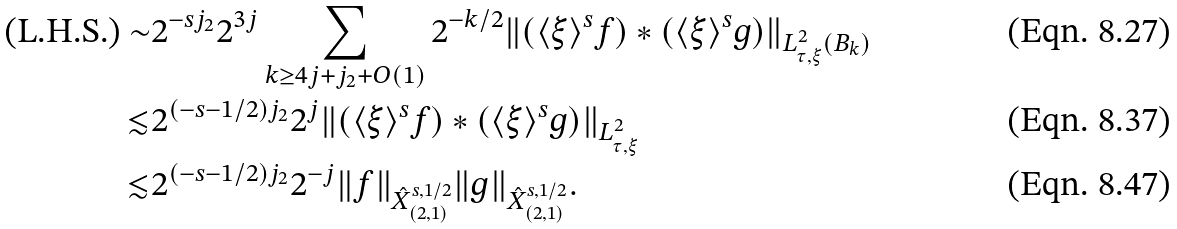<formula> <loc_0><loc_0><loc_500><loc_500>\text {(L.H.S.)} \sim & 2 ^ { - s j _ { 2 } } 2 ^ { 3 j } \sum _ { k \geq 4 j + j _ { 2 } + O ( 1 ) } 2 ^ { - k / 2 } \| ( \langle \xi \rangle ^ { s } f ) * ( \langle \xi \rangle ^ { s } g ) \| _ { L _ { \tau , \xi } ^ { 2 } ( B _ { k } ) } \\ \lesssim & 2 ^ { ( - s - 1 / 2 ) j _ { 2 } } 2 ^ { j } \| ( \langle \xi \rangle ^ { s } f ) * ( \langle \xi \rangle ^ { s } g ) \| _ { L _ { \tau , \xi } ^ { 2 } } \\ \lesssim & 2 ^ { ( - s - 1 / 2 ) j _ { 2 } } 2 ^ { - j } \| f \| _ { \hat { X } _ { ( 2 , 1 ) } ^ { s , 1 / 2 } } \| g \| _ { \hat { X } _ { ( 2 , 1 ) } ^ { s , 1 / 2 } } .</formula> 